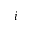<formula> <loc_0><loc_0><loc_500><loc_500>i</formula> 